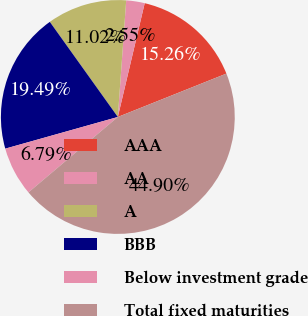<chart> <loc_0><loc_0><loc_500><loc_500><pie_chart><fcel>AAA<fcel>AA<fcel>A<fcel>BBB<fcel>Below investment grade<fcel>Total fixed maturities<nl><fcel>15.26%<fcel>2.55%<fcel>11.02%<fcel>19.49%<fcel>6.79%<fcel>44.9%<nl></chart> 